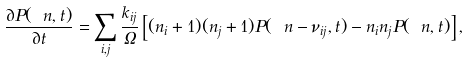Convert formula to latex. <formula><loc_0><loc_0><loc_500><loc_500>\frac { \partial P ( \ n , t ) } { \partial t } = \sum _ { i , j } \frac { k _ { i j } } { \Omega } \left [ ( n _ { i } + 1 ) ( n _ { j } + 1 ) P ( \ n - \nu _ { i j } , t ) - n _ { i } n _ { j } P ( \ n , t ) \right ] ,</formula> 